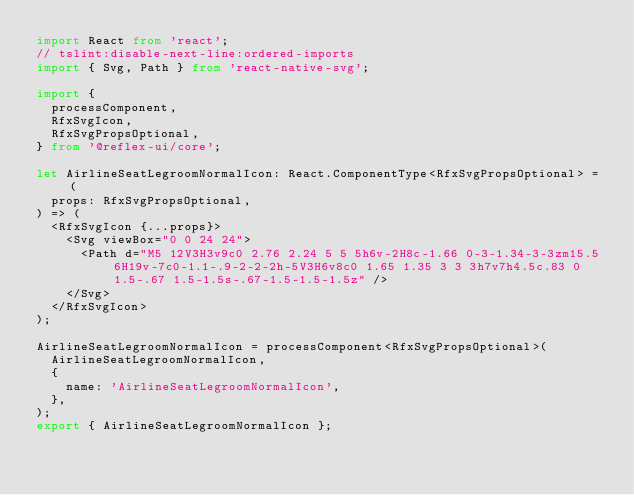<code> <loc_0><loc_0><loc_500><loc_500><_TypeScript_>import React from 'react';
// tslint:disable-next-line:ordered-imports
import { Svg, Path } from 'react-native-svg';

import {
  processComponent,
  RfxSvgIcon,
  RfxSvgPropsOptional,
} from '@reflex-ui/core';

let AirlineSeatLegroomNormalIcon: React.ComponentType<RfxSvgPropsOptional> = (
  props: RfxSvgPropsOptional,
) => (
  <RfxSvgIcon {...props}>
    <Svg viewBox="0 0 24 24">
      <Path d="M5 12V3H3v9c0 2.76 2.24 5 5 5h6v-2H8c-1.66 0-3-1.34-3-3zm15.5 6H19v-7c0-1.1-.9-2-2-2h-5V3H6v8c0 1.65 1.35 3 3 3h7v7h4.5c.83 0 1.5-.67 1.5-1.5s-.67-1.5-1.5-1.5z" />
    </Svg>
  </RfxSvgIcon>
);

AirlineSeatLegroomNormalIcon = processComponent<RfxSvgPropsOptional>(
  AirlineSeatLegroomNormalIcon,
  {
    name: 'AirlineSeatLegroomNormalIcon',
  },
);
export { AirlineSeatLegroomNormalIcon };
</code> 